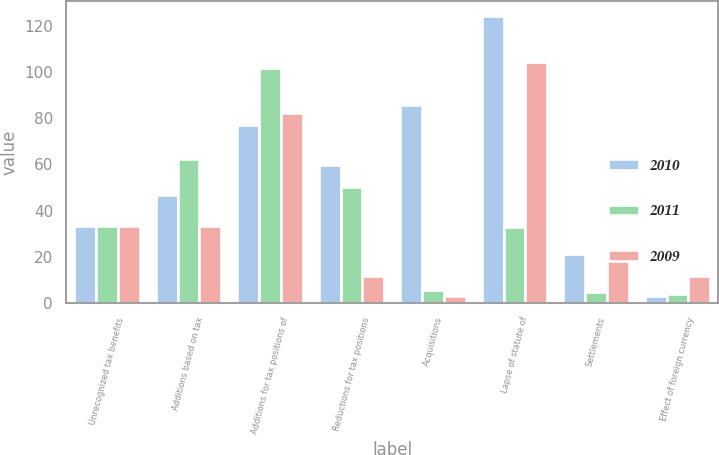<chart> <loc_0><loc_0><loc_500><loc_500><stacked_bar_chart><ecel><fcel>Unrecognized tax benefits<fcel>Additions based on tax<fcel>Additions for tax positions of<fcel>Reductions for tax positions<fcel>Acquisitions<fcel>Lapse of statute of<fcel>Settlements<fcel>Effect of foreign currency<nl><fcel>2010<fcel>33.4<fcel>46.6<fcel>77.1<fcel>59.7<fcel>85.5<fcel>124.3<fcel>21.2<fcel>3.2<nl><fcel>2011<fcel>33.4<fcel>62.2<fcel>101.8<fcel>50<fcel>5.7<fcel>32.8<fcel>4.9<fcel>3.8<nl><fcel>2009<fcel>33.4<fcel>33.4<fcel>82.3<fcel>11.8<fcel>3<fcel>104.5<fcel>21.6<fcel>11.6<nl></chart> 